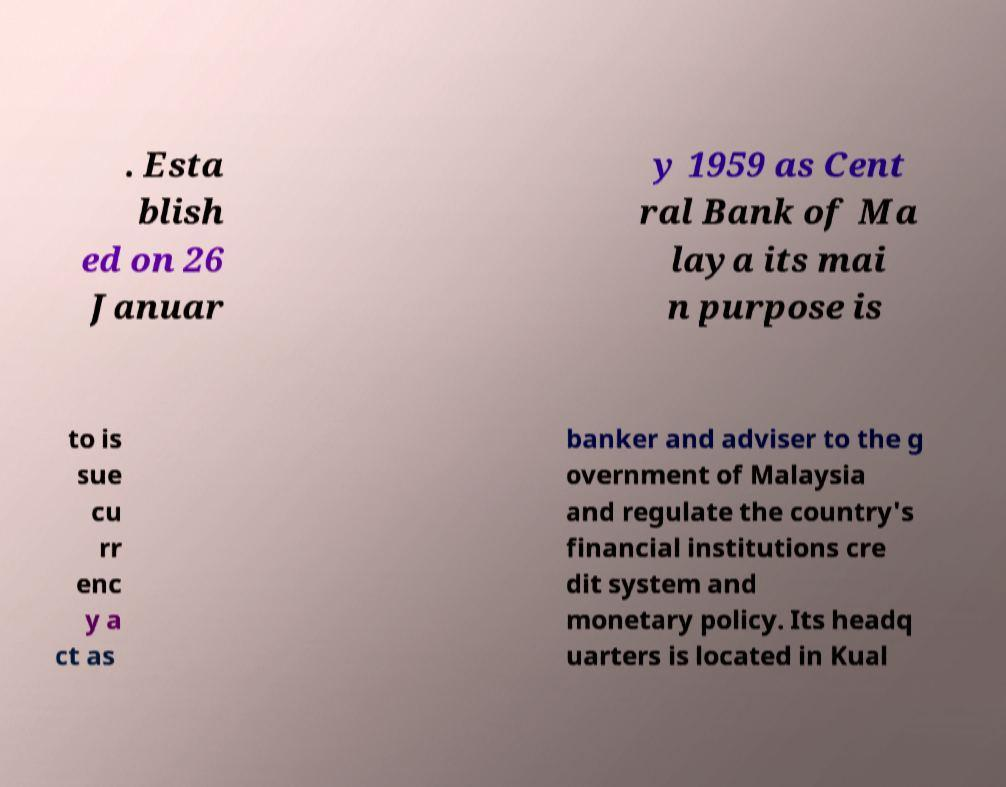There's text embedded in this image that I need extracted. Can you transcribe it verbatim? . Esta blish ed on 26 Januar y 1959 as Cent ral Bank of Ma laya its mai n purpose is to is sue cu rr enc y a ct as banker and adviser to the g overnment of Malaysia and regulate the country's financial institutions cre dit system and monetary policy. Its headq uarters is located in Kual 